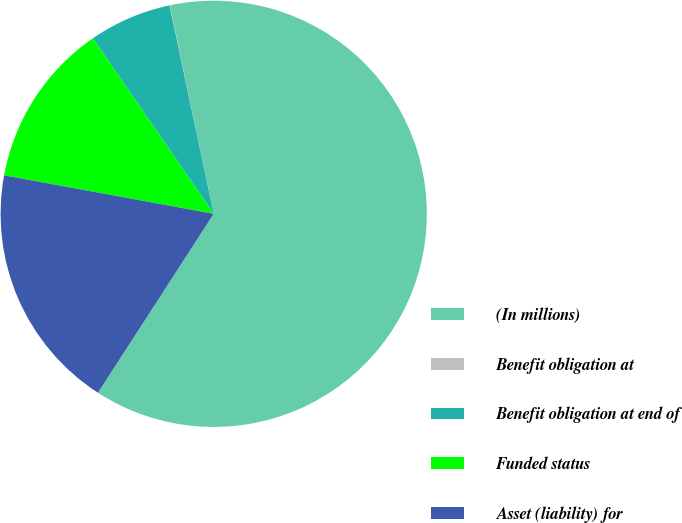Convert chart. <chart><loc_0><loc_0><loc_500><loc_500><pie_chart><fcel>(In millions)<fcel>Benefit obligation at<fcel>Benefit obligation at end of<fcel>Funded status<fcel>Asset (liability) for<nl><fcel>62.43%<fcel>0.03%<fcel>6.27%<fcel>12.51%<fcel>18.75%<nl></chart> 